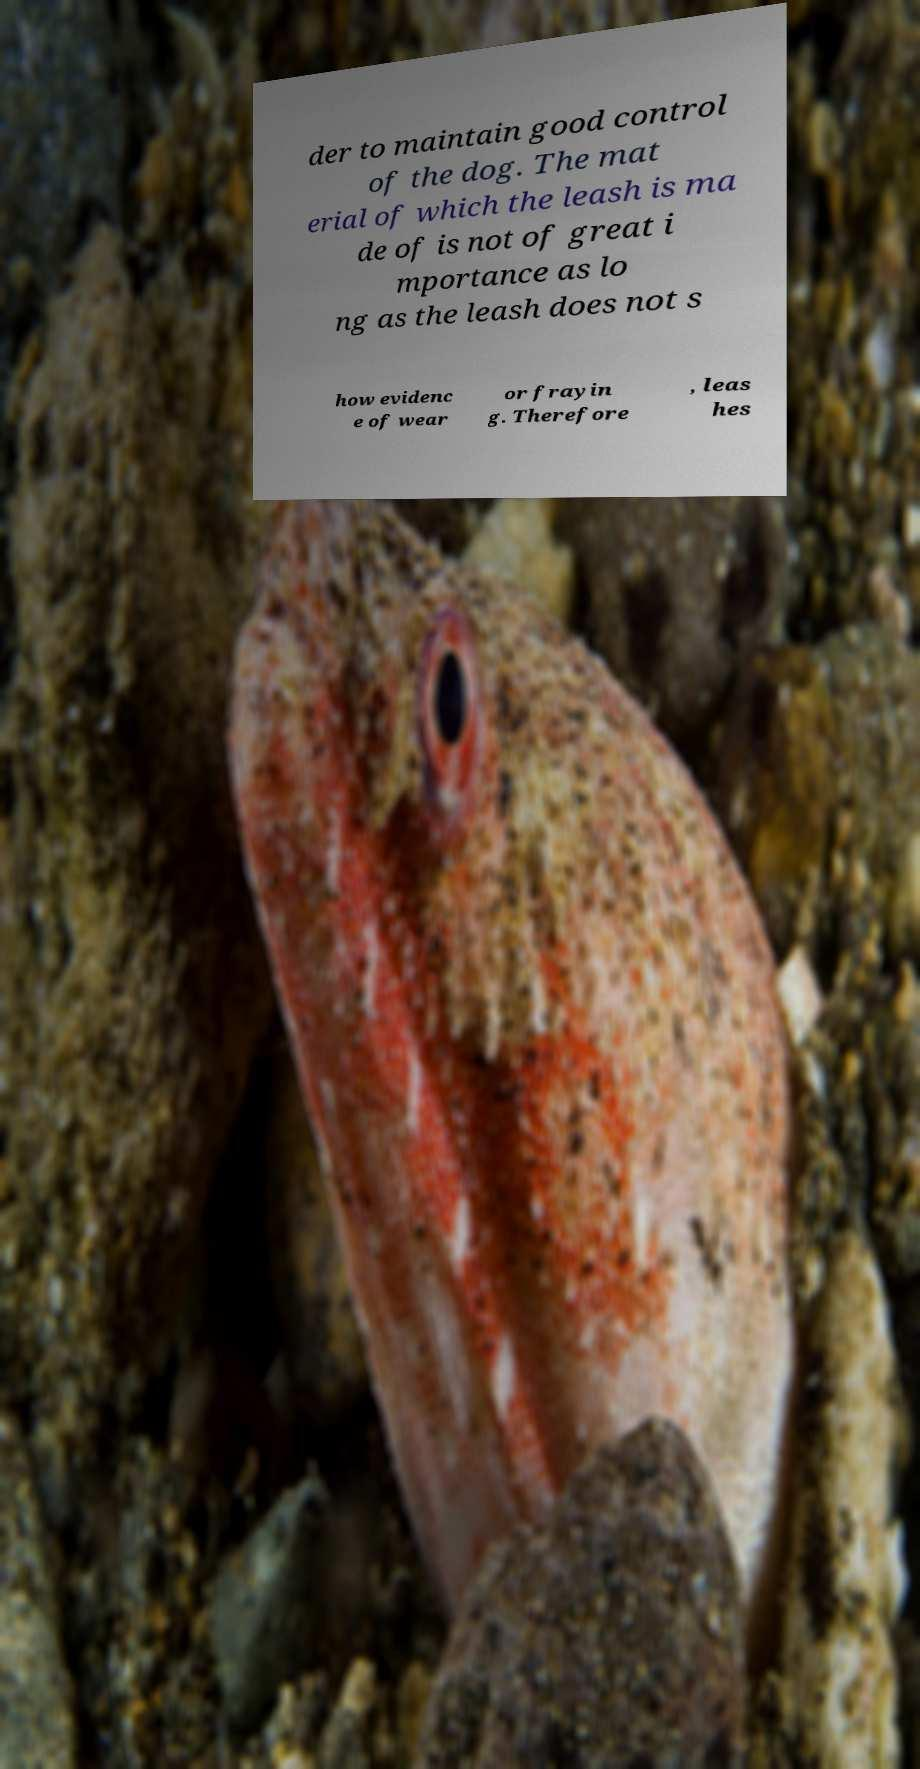I need the written content from this picture converted into text. Can you do that? der to maintain good control of the dog. The mat erial of which the leash is ma de of is not of great i mportance as lo ng as the leash does not s how evidenc e of wear or frayin g. Therefore , leas hes 